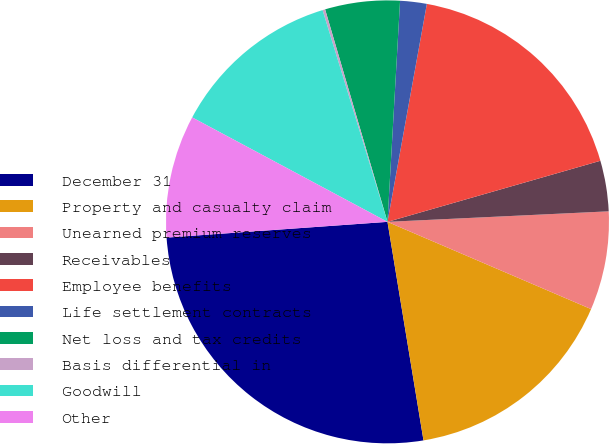Convert chart to OTSL. <chart><loc_0><loc_0><loc_500><loc_500><pie_chart><fcel>December 31<fcel>Property and casualty claim<fcel>Unearned premium reserves<fcel>Receivables<fcel>Employee benefits<fcel>Life settlement contracts<fcel>Net loss and tax credits<fcel>Basis differential in<fcel>Goodwill<fcel>Other<nl><fcel>26.47%<fcel>15.96%<fcel>7.2%<fcel>3.69%<fcel>17.71%<fcel>1.94%<fcel>5.45%<fcel>0.19%<fcel>12.45%<fcel>8.95%<nl></chart> 